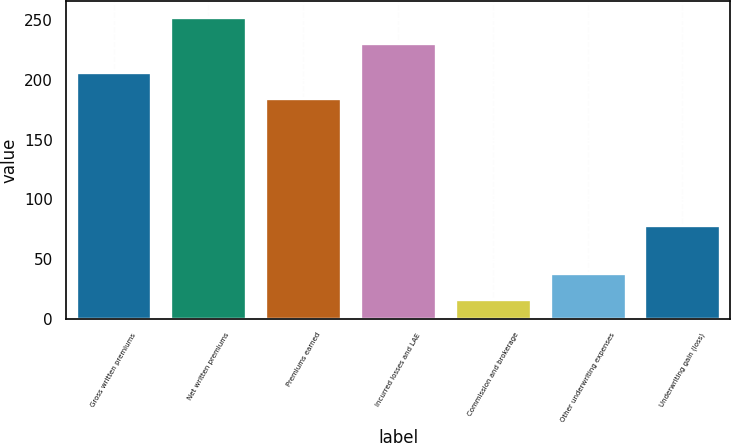Convert chart to OTSL. <chart><loc_0><loc_0><loc_500><loc_500><bar_chart><fcel>Gross written premiums<fcel>Net written premiums<fcel>Premiums earned<fcel>Incurred losses and LAE<fcel>Commission and brokerage<fcel>Other underwriting expenses<fcel>Underwriting gain (loss)<nl><fcel>206.8<fcel>253<fcel>185<fcel>231.2<fcel>16.1<fcel>37.9<fcel>78.6<nl></chart> 